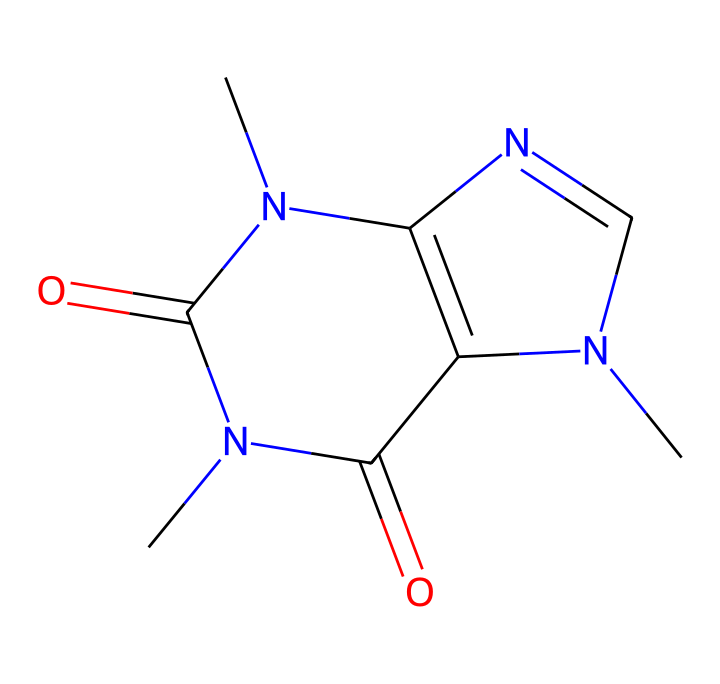What is the molecular formula of caffeine? To find the molecular formula, we interpret the SMILES representation. The SMILES indicates the presence of carbon (C), hydrogen (H), nitrogen (N), and oxygen (O) atoms. By counting the atoms, we find that caffeine has 8 carbon, 10 hydrogen, 4 nitrogen, and 2 oxygen. Therefore, the molecular formula is C8H10N4O2.
Answer: C8H10N4O2 How many nitrogen atoms are in caffeine? By analyzing the SMILES representation, we can see that nitrogen atoms are denoted by 'N'. In this structure, there are a total of 4 nitrogen atoms present.
Answer: 4 What type of chemical compound is caffeine? Caffeine is classified as a xanthine alkaloid based on its chemical structure, which is reflected in the arrangement of nitrogen and carbon atoms, as well as its physiological effects.
Answer: xanthine alkaloid Which functional groups are present in caffeine? The SMILES notation reveals that caffeine possesses carbonyl (C=O) groups and amine (N-H) groups. The presence of these groups contributes to both its structure and pharmacological properties.
Answer: carbonyl and amine What is the total number of rings in the caffeine structure? Analyzing the SMILES, we observe that it contains two fused rings, which are indicated by the N and C atoms in a cyclic arrangement. These two rings define the structural features of caffeine.
Answer: 2 Which element predominates the structure of caffeine? By analyzing the atom count from the molecular formula, we see that carbon is the most abundant element, with a total of 8 carbon atoms in the structure which is more than any other element present.
Answer: carbon 